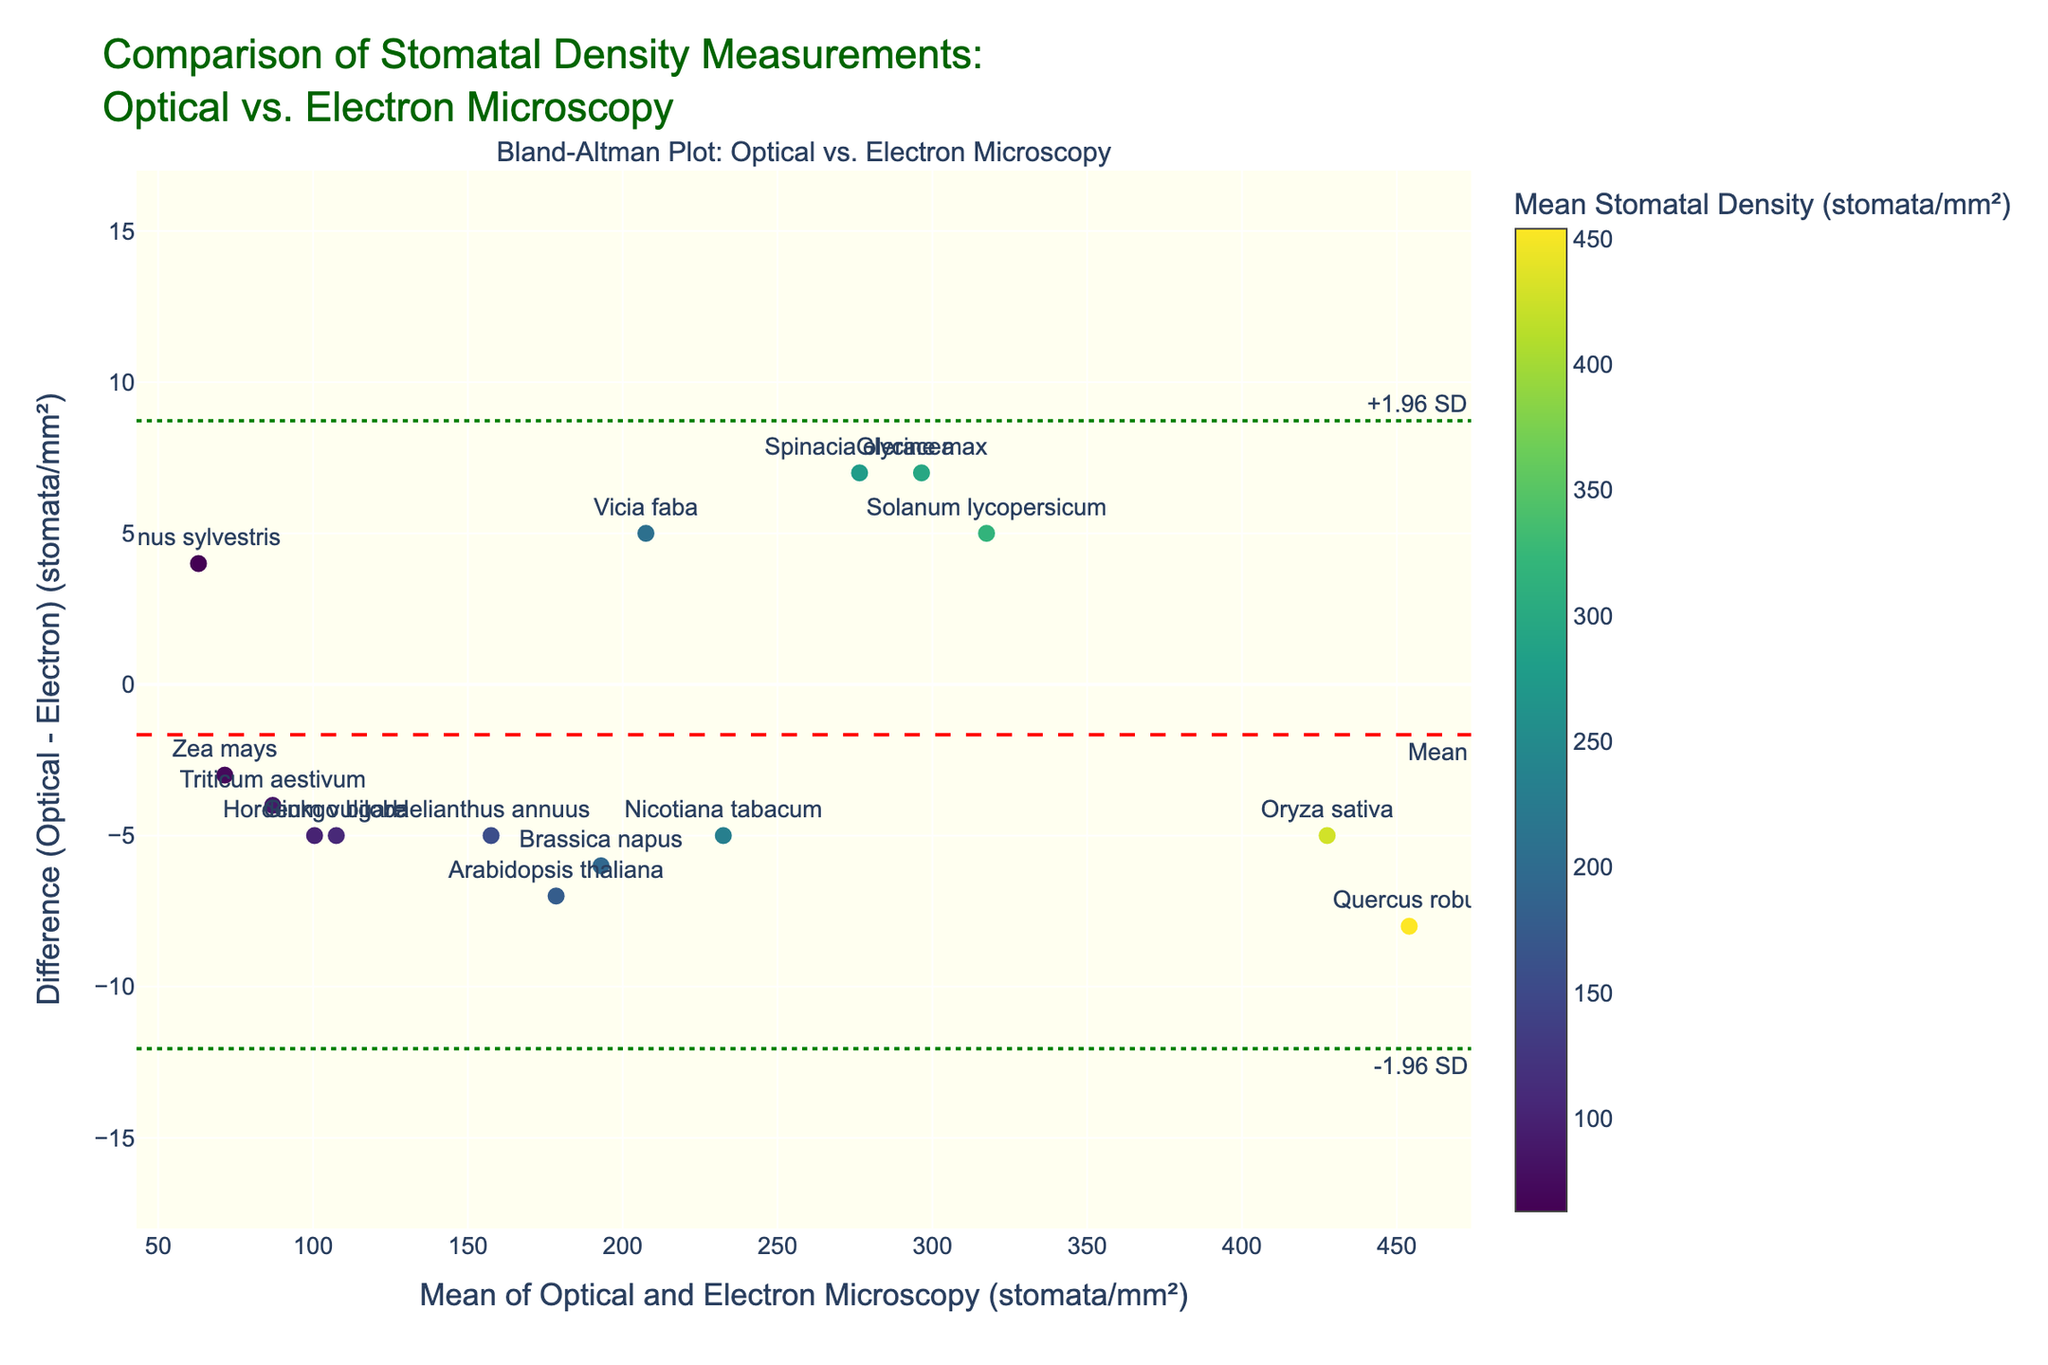What is the title of the figure? The title is located at the top of the figure, typically in a larger font than other text. It reads "Comparison of Stomatal Density Measurements: Optical vs. Electron Microscopy."
Answer: Comparison of Stomatal Density Measurements: Optical vs. Electron Microscopy What are the x-axis and y-axis representing? The labels on the axes state their contents. The x-axis represents "Mean of Optical and Electron Microscopy (stomata/mm²)" and the y-axis represents "Difference (Optical - Electron) (stomata/mm²)."
Answer: The x-axis represents "Mean of Optical and Electron Microscopy (stomata/mm²)" and the y-axis represents "Difference (Optical - Electron) (stomata/mm²)." How many data points are shown in the plot? By counting the individual scatter points on the plot corresponding to each plant species, we find there are 15 data points.
Answer: 15 Which plant species has the largest mean stomatal density? We identify the data point with the highest x-axis value, and the hover text or annotations help us find that it corresponds to "Quercus robur."
Answer: Quercus robur Which plant species shows the greatest difference in stomatal density measurements between the two methods? By locating the data point farthest from the y-axis (0), either in the positive or negative direction, it is evident that "Quercus robur" shows the greatest difference.
Answer: Quercus robur What is the mean difference in stomatal density measurements between the two methods? A horizontal dashed red line represents the mean difference. This line is annotated with "Mean." The numerical value, which can be seen near the line or inferred from the y-axis scale, shows that the mean difference is approximately 0.2 stomata/mm².
Answer: 0.2 stomata/mm² What are the limits of agreement for the stomatal density differences? The figure includes two green dotted lines which mark ±1.96 times the standard deviation from the mean difference. These lines are annotated with "-1.96 SD" and "+1.96 SD." The numerical values can be estimated from the position of these lines on the y-axis. They are roughly -7.8 and 8.2 stomata/mm².
Answer: -7.8 and 8.2 stomata/mm² For which plant species is the stomatal density higher when measured by optical microscopy compared to scanning electron microscopy? We look for data points where the y-value (Difference) is positive, indicating that the Optical Microscopy measure is higher. These species include "Pinus sylvestris" and "Spinacia oleracea."
Answer: Pinus sylvestris and Spinacia oleracea What is the stomatal density difference for "Arabidopsis thaliana"? Referring to the hover text or the label next to the point corresponding to "Arabidopsis thaliana," we observe the data point to find the specific y-value, which is 7 stomata/mm².
Answer: 7 stomata/mm² How does the stomatal density measurement for "Triticum aestivum" compare across the two methods? By checking the y-value (Difference) associated with "Triticum aestivum," we find it is -4 stomata/mm², indicating the Electron Microscopy measure is higher by 4 units.
Answer: Electron Microscopy is higher by 4 stomata/mm² 